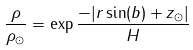Convert formula to latex. <formula><loc_0><loc_0><loc_500><loc_500>\frac { \rho } { \rho _ { \odot } } = \exp { \frac { - | r \sin ( b ) + z _ { \odot } | } { H } }</formula> 